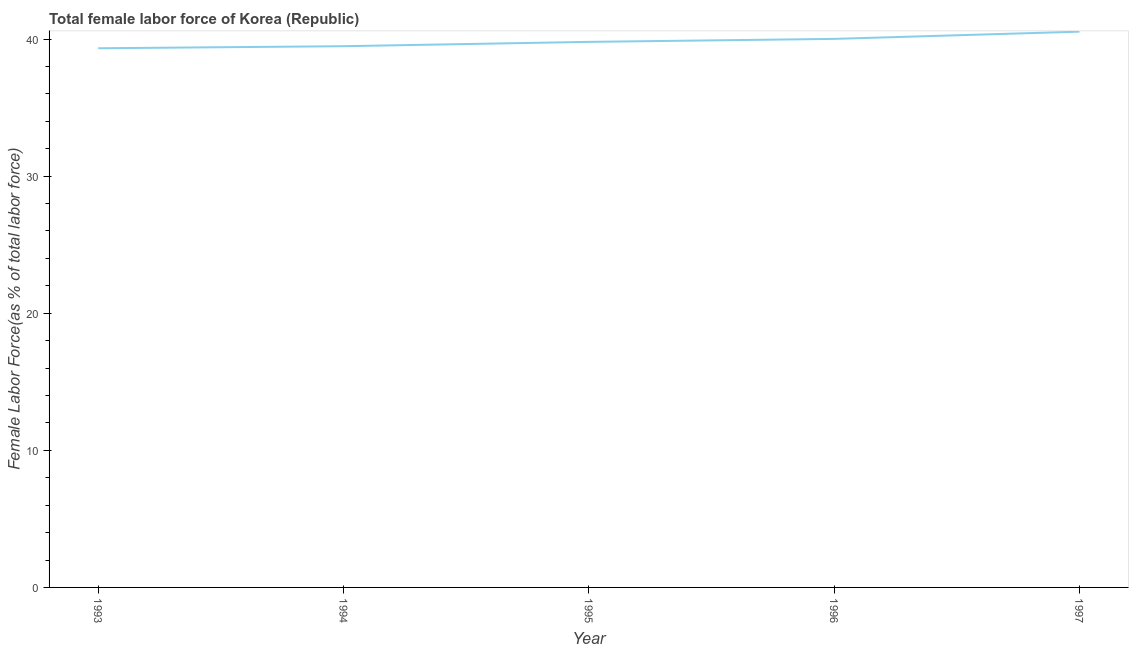What is the total female labor force in 1995?
Make the answer very short. 39.79. Across all years, what is the maximum total female labor force?
Provide a short and direct response. 40.54. Across all years, what is the minimum total female labor force?
Keep it short and to the point. 39.33. What is the sum of the total female labor force?
Keep it short and to the point. 199.15. What is the difference between the total female labor force in 1994 and 1995?
Your answer should be very brief. -0.32. What is the average total female labor force per year?
Make the answer very short. 39.83. What is the median total female labor force?
Your response must be concise. 39.79. Do a majority of the years between 1996 and 1997 (inclusive) have total female labor force greater than 32 %?
Offer a very short reply. Yes. What is the ratio of the total female labor force in 1994 to that in 1996?
Give a very brief answer. 0.99. What is the difference between the highest and the second highest total female labor force?
Offer a terse response. 0.53. Is the sum of the total female labor force in 1993 and 1997 greater than the maximum total female labor force across all years?
Keep it short and to the point. Yes. What is the difference between the highest and the lowest total female labor force?
Your response must be concise. 1.21. How many lines are there?
Provide a short and direct response. 1. Are the values on the major ticks of Y-axis written in scientific E-notation?
Give a very brief answer. No. What is the title of the graph?
Keep it short and to the point. Total female labor force of Korea (Republic). What is the label or title of the X-axis?
Give a very brief answer. Year. What is the label or title of the Y-axis?
Offer a very short reply. Female Labor Force(as % of total labor force). What is the Female Labor Force(as % of total labor force) of 1993?
Keep it short and to the point. 39.33. What is the Female Labor Force(as % of total labor force) in 1994?
Ensure brevity in your answer.  39.48. What is the Female Labor Force(as % of total labor force) in 1995?
Your response must be concise. 39.79. What is the Female Labor Force(as % of total labor force) of 1996?
Offer a terse response. 40.01. What is the Female Labor Force(as % of total labor force) in 1997?
Offer a terse response. 40.54. What is the difference between the Female Labor Force(as % of total labor force) in 1993 and 1994?
Give a very brief answer. -0.15. What is the difference between the Female Labor Force(as % of total labor force) in 1993 and 1995?
Offer a terse response. -0.47. What is the difference between the Female Labor Force(as % of total labor force) in 1993 and 1996?
Provide a short and direct response. -0.68. What is the difference between the Female Labor Force(as % of total labor force) in 1993 and 1997?
Keep it short and to the point. -1.21. What is the difference between the Female Labor Force(as % of total labor force) in 1994 and 1995?
Offer a very short reply. -0.32. What is the difference between the Female Labor Force(as % of total labor force) in 1994 and 1996?
Your answer should be compact. -0.53. What is the difference between the Female Labor Force(as % of total labor force) in 1994 and 1997?
Ensure brevity in your answer.  -1.06. What is the difference between the Female Labor Force(as % of total labor force) in 1995 and 1996?
Ensure brevity in your answer.  -0.22. What is the difference between the Female Labor Force(as % of total labor force) in 1995 and 1997?
Ensure brevity in your answer.  -0.75. What is the difference between the Female Labor Force(as % of total labor force) in 1996 and 1997?
Provide a short and direct response. -0.53. What is the ratio of the Female Labor Force(as % of total labor force) in 1993 to that in 1996?
Your answer should be very brief. 0.98. What is the ratio of the Female Labor Force(as % of total labor force) in 1994 to that in 1995?
Offer a very short reply. 0.99. What is the ratio of the Female Labor Force(as % of total labor force) in 1994 to that in 1996?
Your response must be concise. 0.99. What is the ratio of the Female Labor Force(as % of total labor force) in 1994 to that in 1997?
Your answer should be compact. 0.97. What is the ratio of the Female Labor Force(as % of total labor force) in 1995 to that in 1996?
Give a very brief answer. 0.99. What is the ratio of the Female Labor Force(as % of total labor force) in 1996 to that in 1997?
Your answer should be very brief. 0.99. 